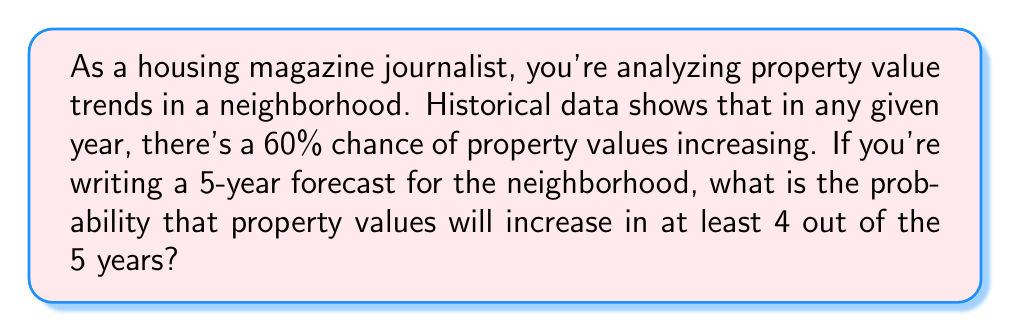Solve this math problem. To solve this problem, we can use the binomial probability distribution. Let's break it down step-by-step:

1) We have a binomial situation because:
   - There are a fixed number of trials (5 years)
   - Each trial has two possible outcomes (increase or no increase)
   - The probability of success (increase) remains constant (60% or 0.6)
   - The trials are independent

2) We want the probability of at least 4 successes out of 5 trials. This means we need to calculate:
   P(4 successes) + P(5 successes)

3) The binomial probability formula is:

   $$P(X = k) = \binom{n}{k} p^k (1-p)^{n-k}$$

   Where:
   $n$ = number of trials
   $k$ = number of successes
   $p$ = probability of success on each trial

4) For 4 successes out of 5:

   $$P(X = 4) = \binom{5}{4} (0.6)^4 (0.4)^1$$
   $$= 5 \cdot 0.1296 \cdot 0.4 = 0.2592$$

5) For 5 successes out of 5:

   $$P(X = 5) = \binom{5}{5} (0.6)^5 (0.4)^0$$
   $$= 1 \cdot 0.07776 \cdot 1 = 0.07776$$

6) The total probability is the sum of these:

   $$P(X \geq 4) = P(X = 4) + P(X = 5) = 0.2592 + 0.07776 = 0.33696$$
Answer: The probability that property values will increase in at least 4 out of the 5 years is approximately 0.33696 or 33.70%. 